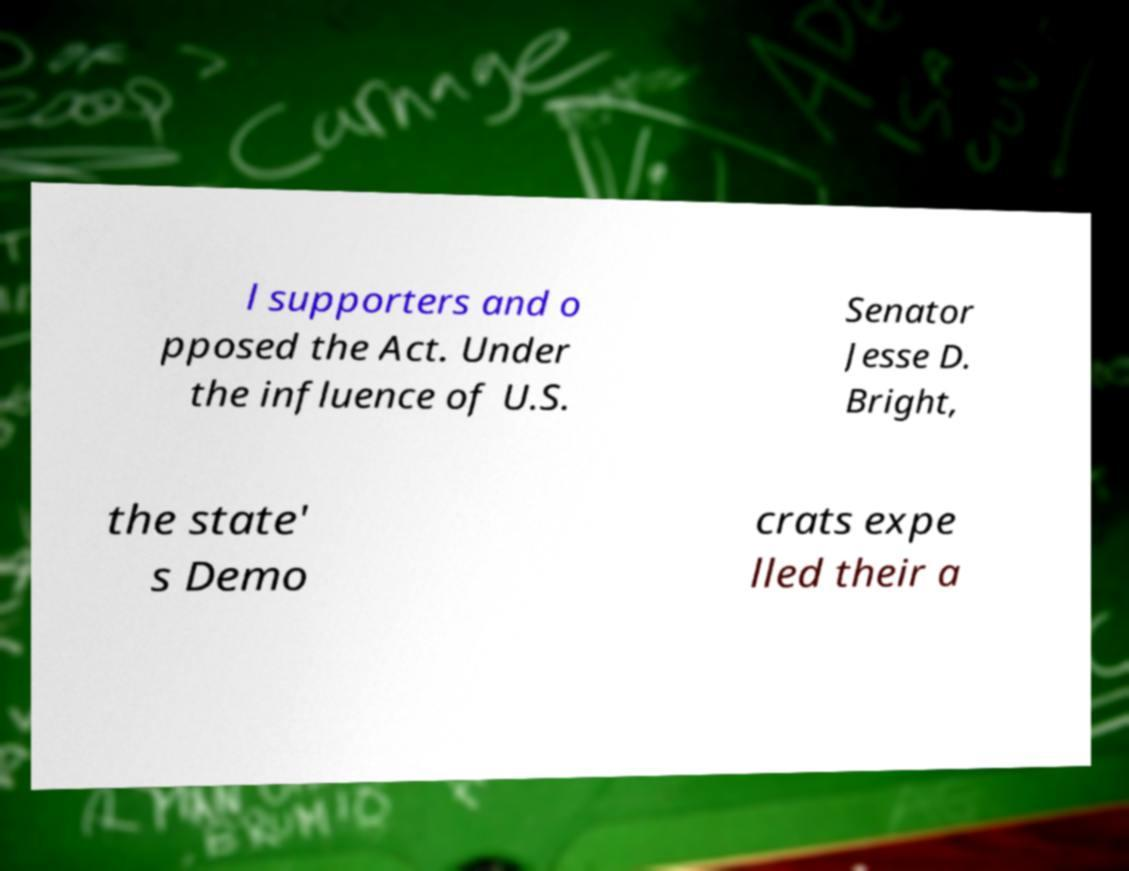Please identify and transcribe the text found in this image. l supporters and o pposed the Act. Under the influence of U.S. Senator Jesse D. Bright, the state' s Demo crats expe lled their a 